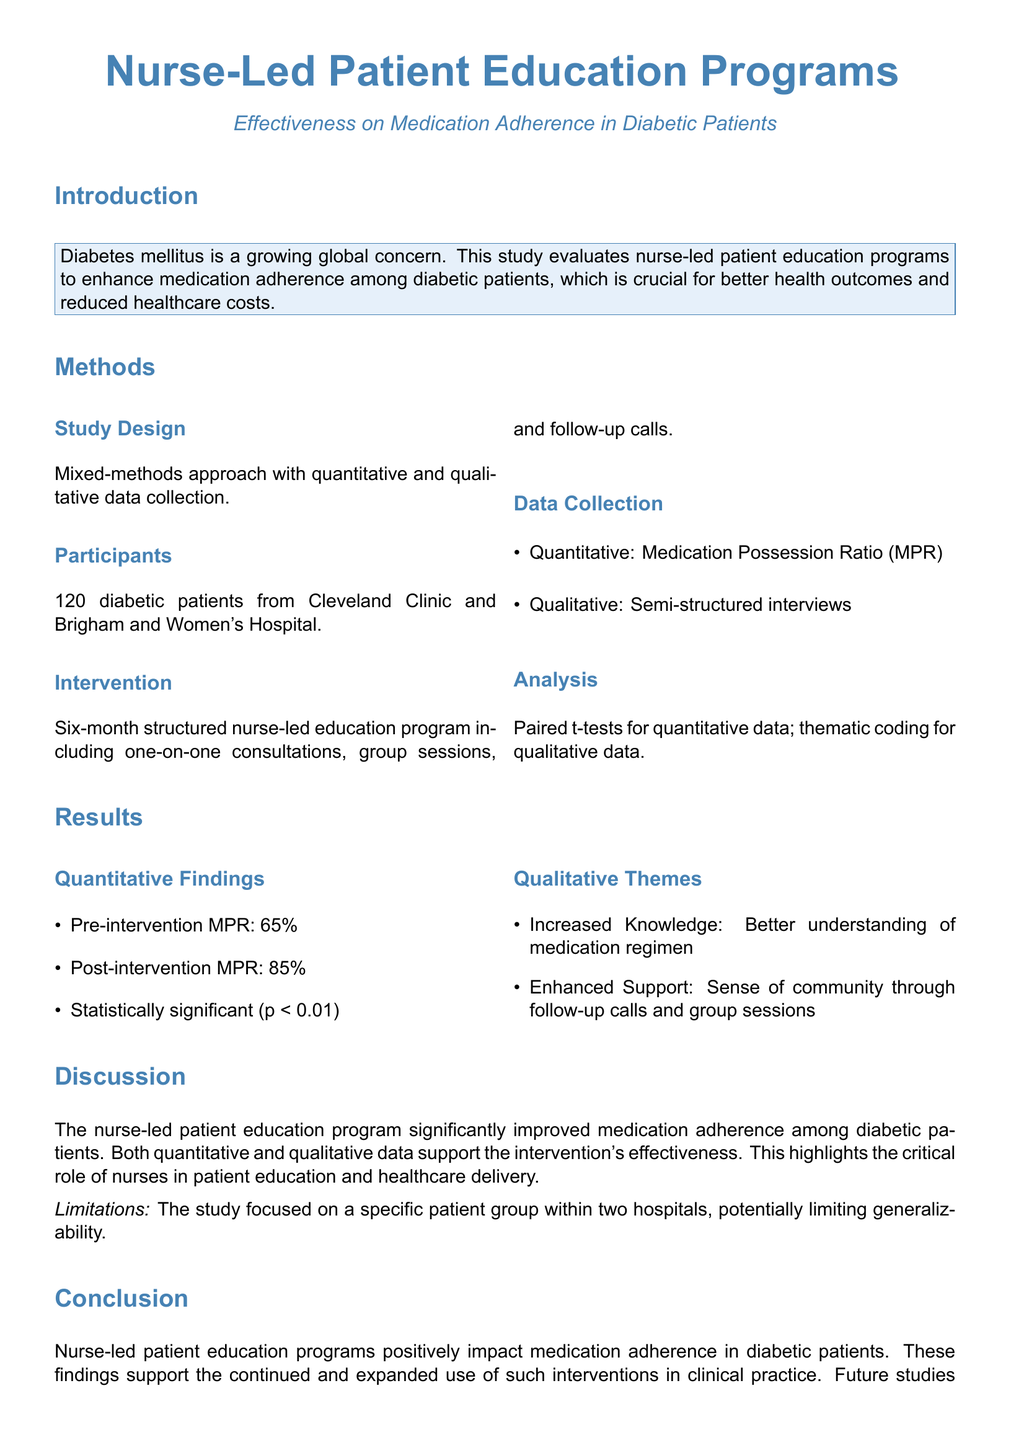what is the primary focus of the study? The primary focus of the study is to evaluate nurse-led patient education programs to enhance medication adherence among diabetic patients.
Answer: enhancing medication adherence how many diabetic patients participated in the study? The number of diabetic patients who participated in the study is mentioned in the methods section.
Answer: 120 what was the pre-intervention Medication Possession Ratio? The pre-intervention MPR is reported in the results section.
Answer: 65% what type of analysis was used for qualitative data? The type of analysis for qualitative data is specified in the methods section.
Answer: thematic coding what significant change was observed in the post-intervention MPR? The change in MPR is summarized in the results section with a specific percentage.
Answer: 85% what is one of the qualitative themes identified from interviews? One qualitative theme identified is mentioned in the results section.
Answer: Increased Knowledge what statistical significance level was reported in the study? The level of statistical significance is mentioned in the results section.
Answer: p < 0.01 what recommendation is made for future studies? The recommendation for future studies highlights what should be done to validate findings.
Answer: larger sample sizes across multiple healthcare settings 